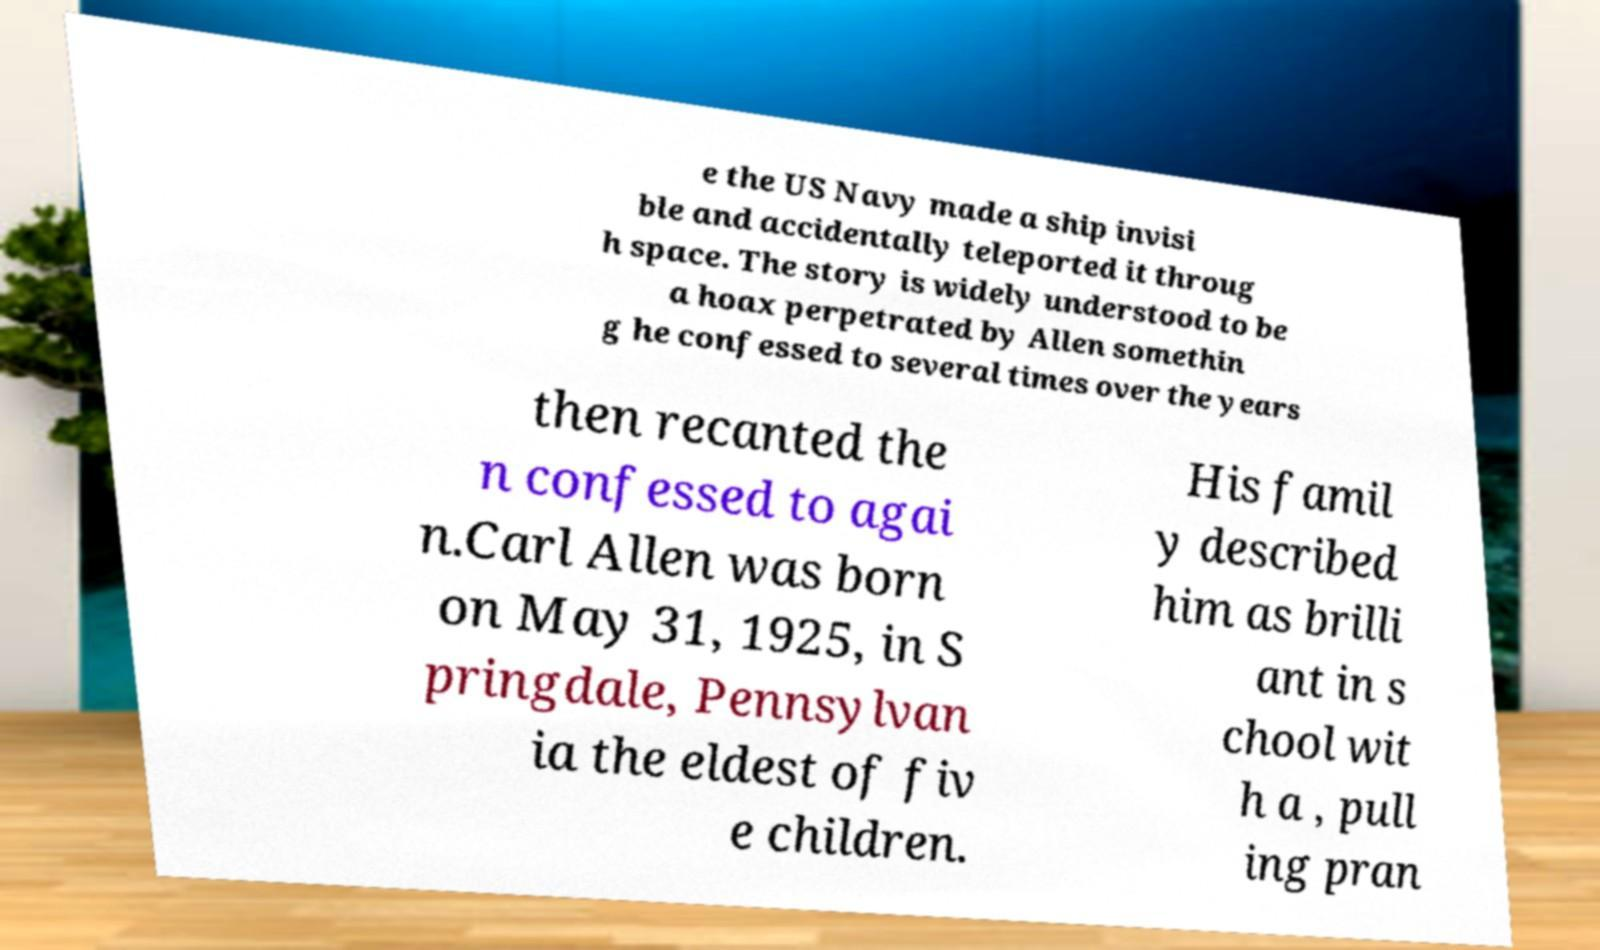For documentation purposes, I need the text within this image transcribed. Could you provide that? e the US Navy made a ship invisi ble and accidentally teleported it throug h space. The story is widely understood to be a hoax perpetrated by Allen somethin g he confessed to several times over the years then recanted the n confessed to agai n.Carl Allen was born on May 31, 1925, in S pringdale, Pennsylvan ia the eldest of fiv e children. His famil y described him as brilli ant in s chool wit h a , pull ing pran 